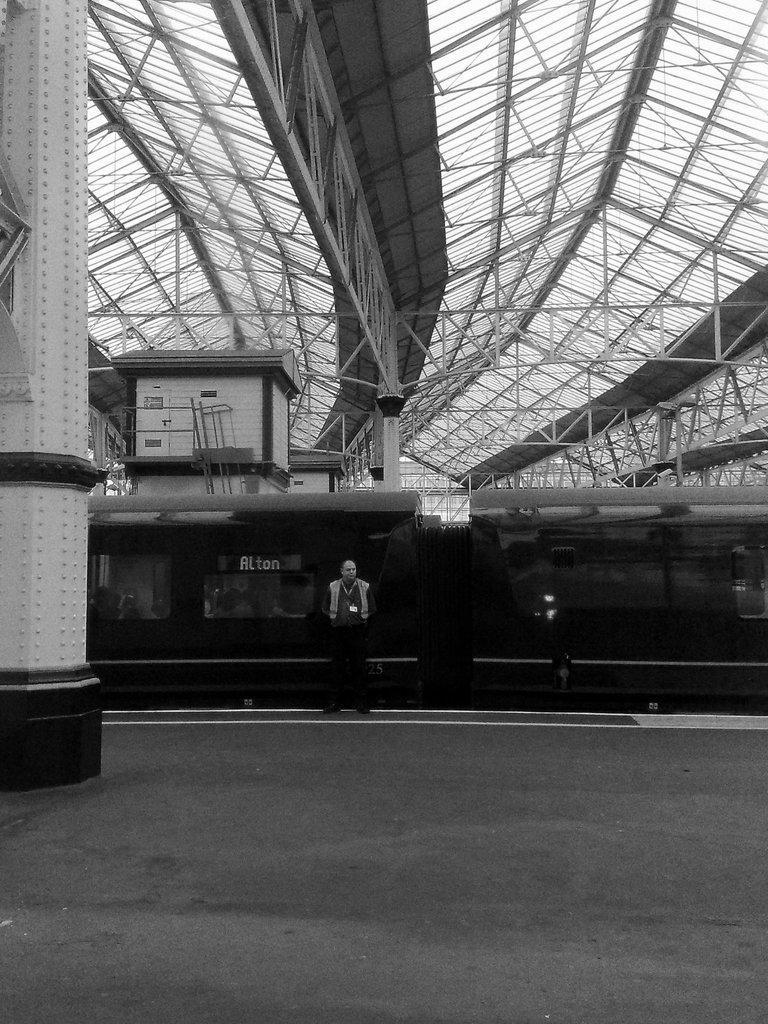In one or two sentences, can you explain what this image depicts? In this image we can see a train, pillar, there is a person standing beside the train, also we can see the rooftop, and the picture is taken in black and white mode. 